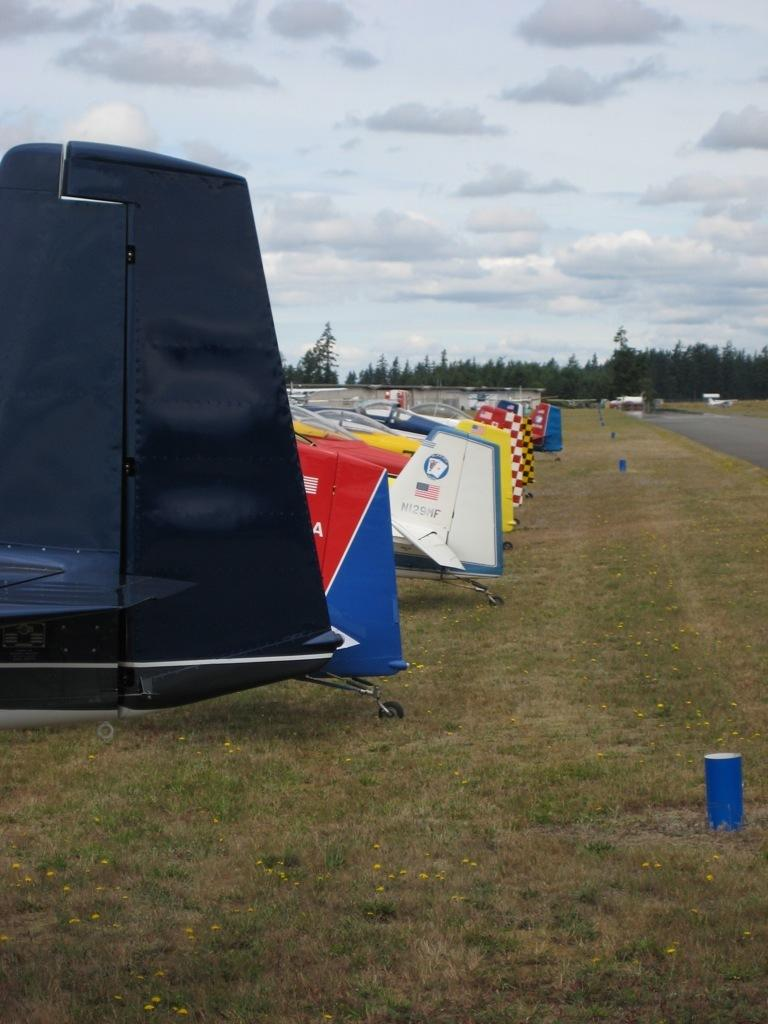What is the main subject of the image? The main subject of the image is planes. What type of natural environment is visible in the image? There is grass and trees visible in the image. What is visible at the top of the image? The sky is visible at the top of the image. What can be seen in the sky? Clouds are present in the sky. Can you tell me how many ducks are swimming in the ocean in the image? There are no ducks or ocean present in the image; it features planes, grass, trees, and a sky with clouds. What is the topic of the argument taking place in the image? There is no argument present in the image; it is a scene with planes, grass, trees, and a sky with clouds. 